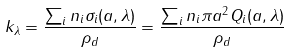<formula> <loc_0><loc_0><loc_500><loc_500>k _ { \lambda } = \frac { \sum _ { i } n _ { i } \sigma _ { i } ( a , \lambda ) } { \rho _ { d } } = \frac { \sum _ { i } n _ { i } \pi a ^ { 2 } Q _ { i } ( a , \lambda ) } { \rho _ { d } }</formula> 